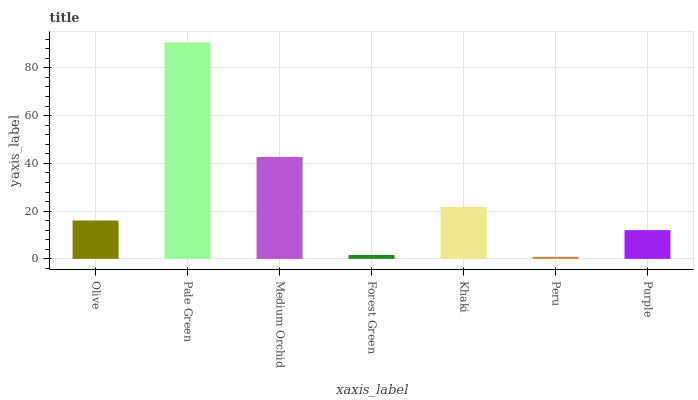Is Peru the minimum?
Answer yes or no. Yes. Is Pale Green the maximum?
Answer yes or no. Yes. Is Medium Orchid the minimum?
Answer yes or no. No. Is Medium Orchid the maximum?
Answer yes or no. No. Is Pale Green greater than Medium Orchid?
Answer yes or no. Yes. Is Medium Orchid less than Pale Green?
Answer yes or no. Yes. Is Medium Orchid greater than Pale Green?
Answer yes or no. No. Is Pale Green less than Medium Orchid?
Answer yes or no. No. Is Olive the high median?
Answer yes or no. Yes. Is Olive the low median?
Answer yes or no. Yes. Is Khaki the high median?
Answer yes or no. No. Is Medium Orchid the low median?
Answer yes or no. No. 